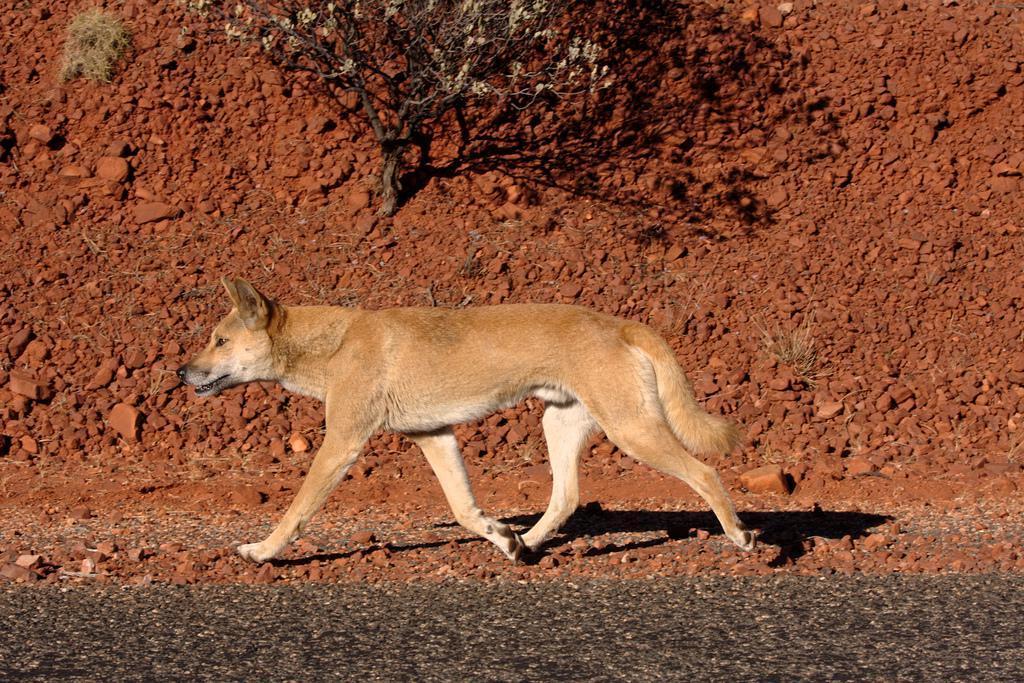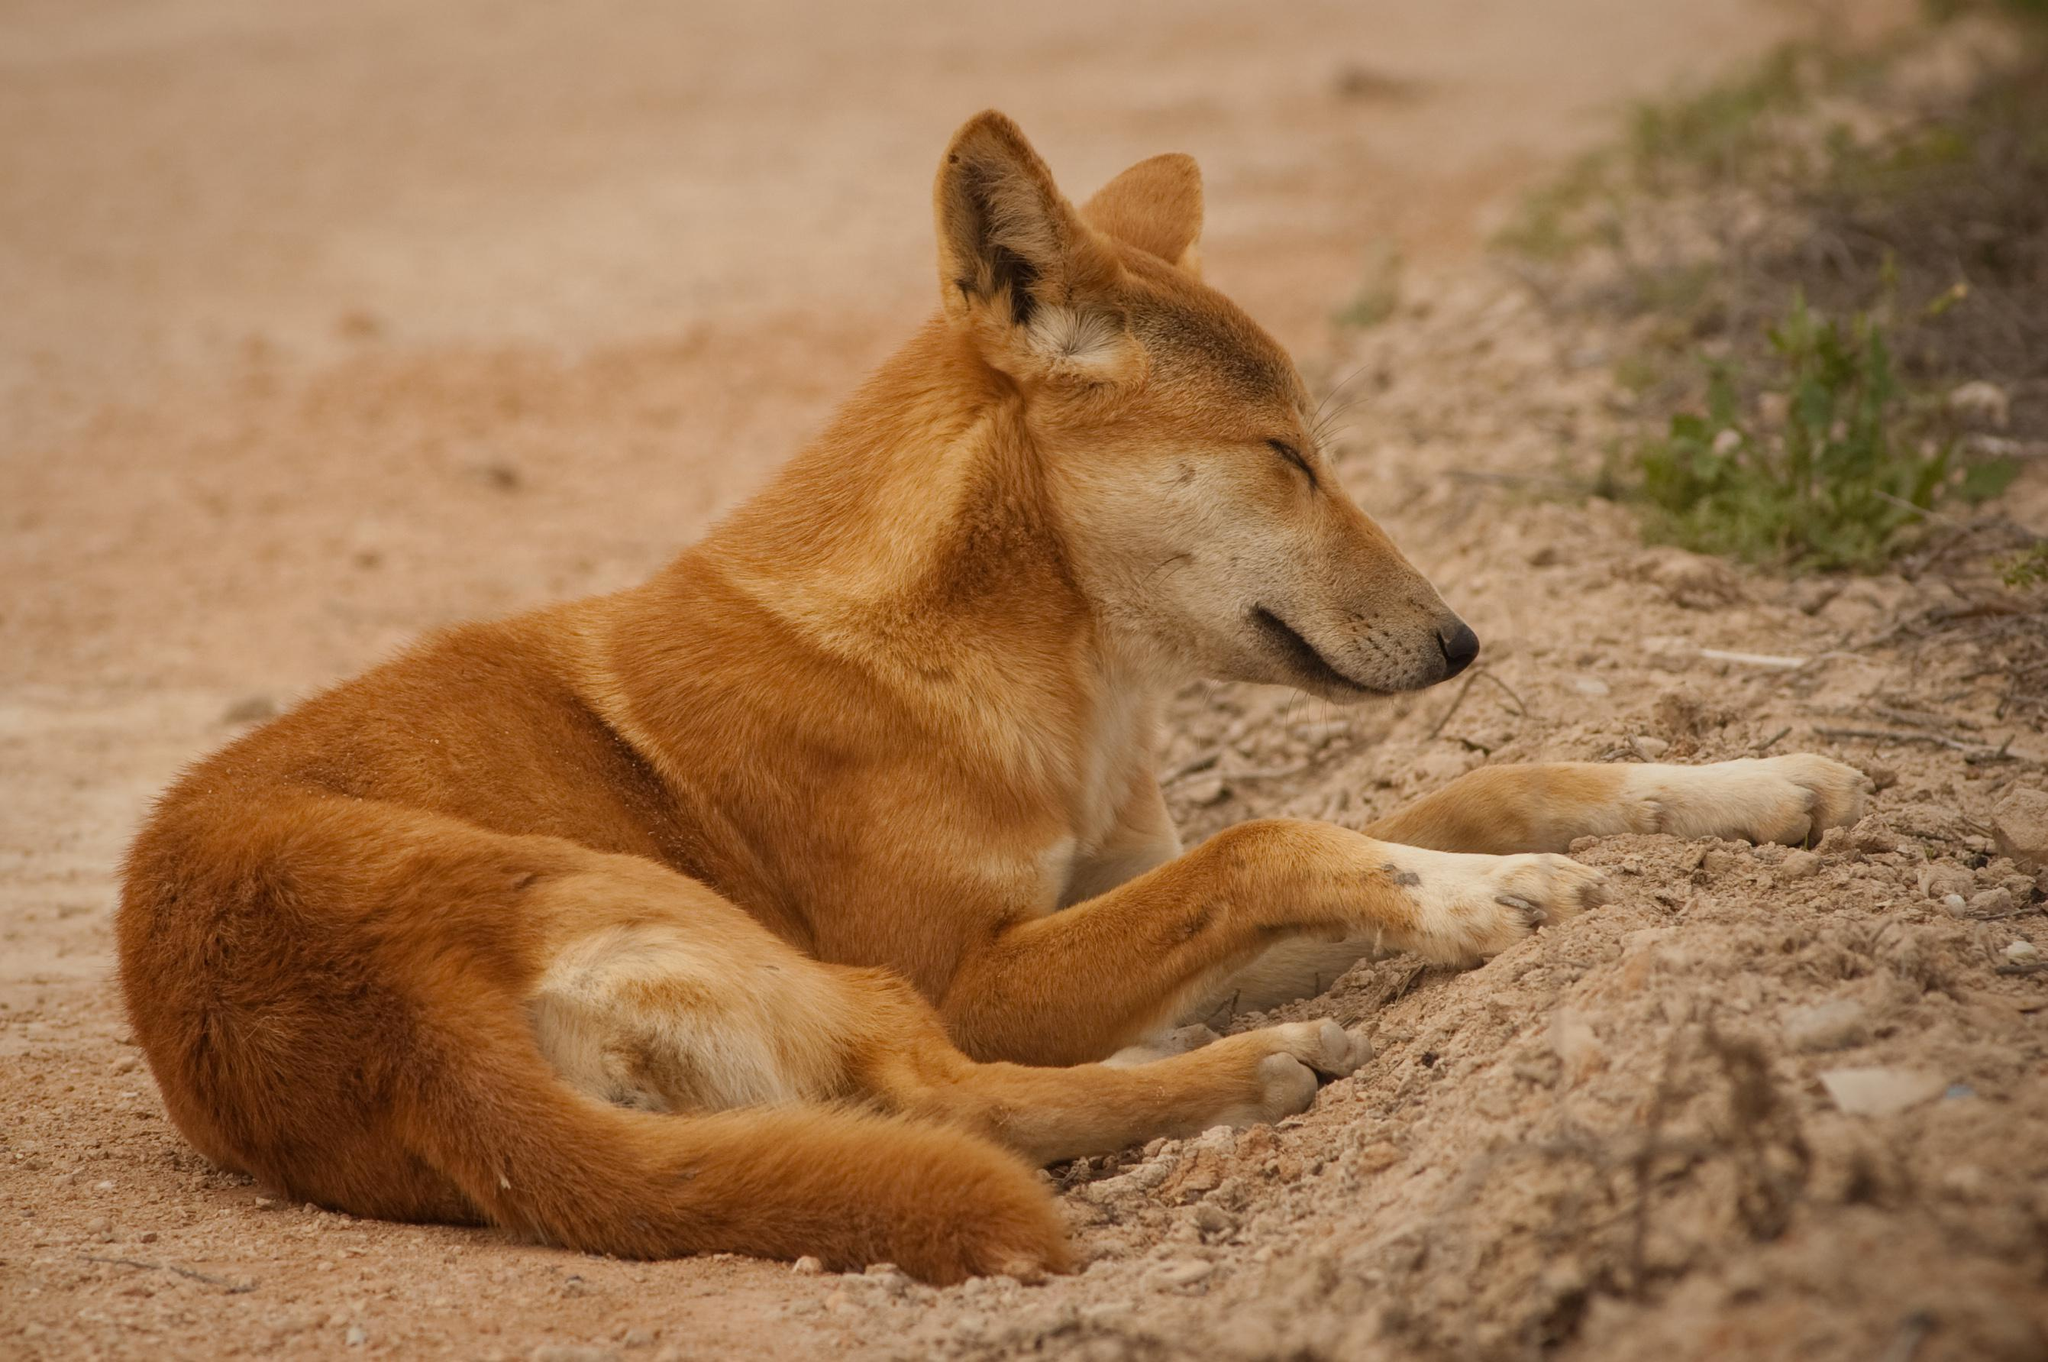The first image is the image on the left, the second image is the image on the right. Assess this claim about the two images: "At least one animal is lying down in one of the images.". Correct or not? Answer yes or no. Yes. The first image is the image on the left, the second image is the image on the right. Analyze the images presented: Is the assertion "The left image includes exactly twice as many wild dogs as the right image." valid? Answer yes or no. No. 